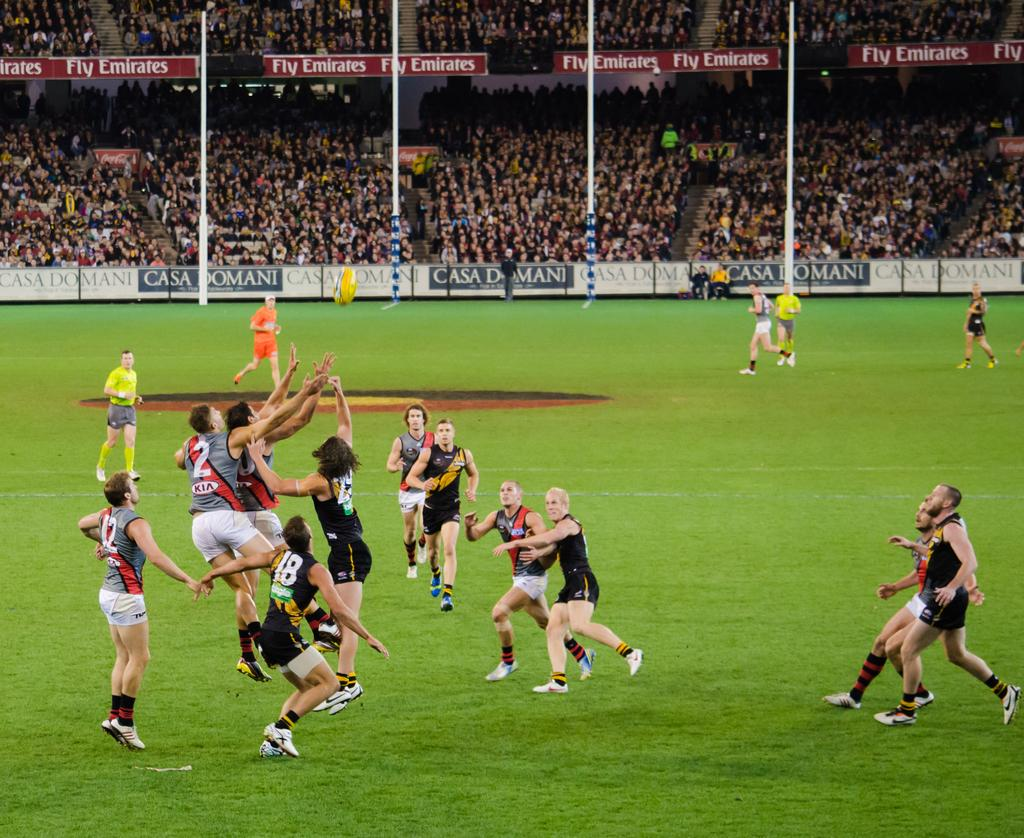<image>
Write a terse but informative summary of the picture. Sports players going for the ball with a sign in the background that says "Casa Di Mani". 